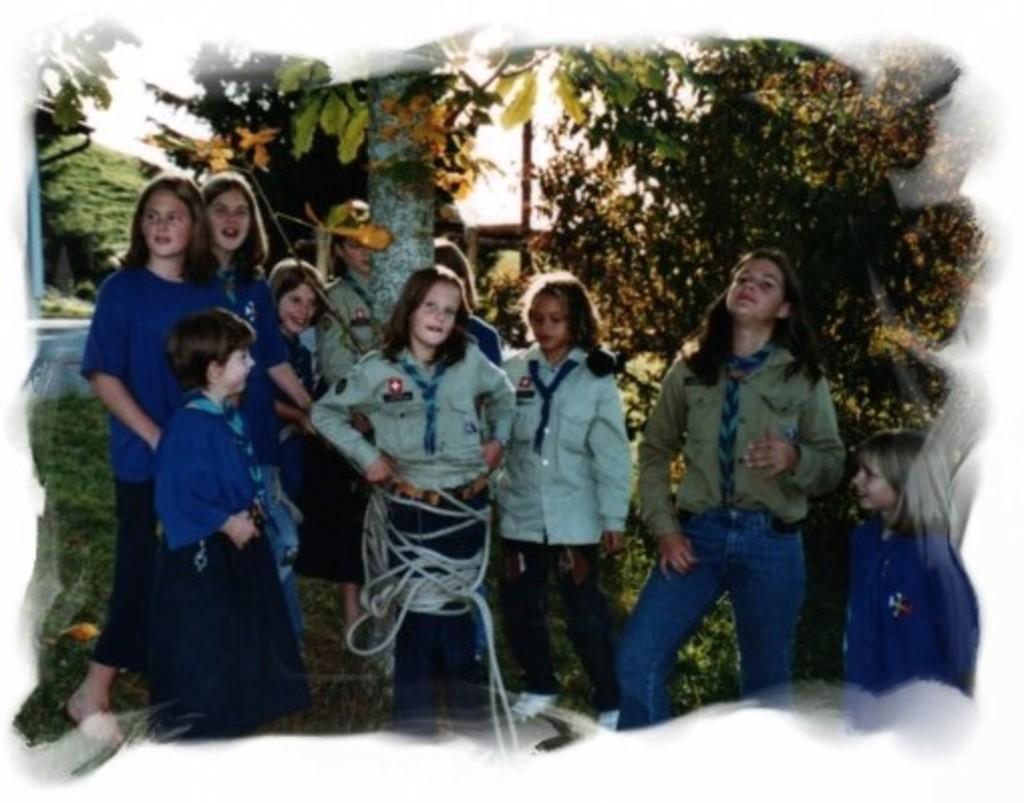How would you summarize this image in a sentence or two? In this image we can see few people. Here we can see grass, rope, and trees. In the background there is sky. 